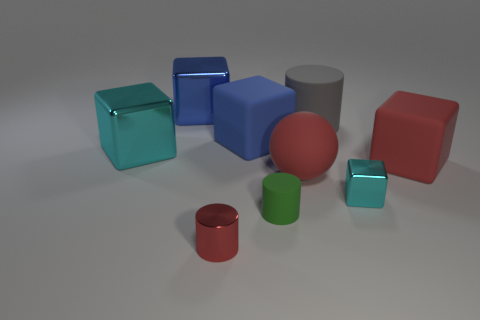How many other objects are there of the same color as the big rubber sphere?
Offer a terse response. 2. What size is the shiny cylinder that is the same color as the big matte sphere?
Provide a short and direct response. Small. How many large objects are either matte cubes or green matte things?
Offer a terse response. 2. Are there more blue metal cubes that are in front of the small red cylinder than small cubes that are left of the ball?
Offer a very short reply. No. Is the tiny red cylinder made of the same material as the large cube right of the green object?
Your answer should be very brief. No. What is the color of the tiny metallic block?
Your response must be concise. Cyan. There is a large metal object that is behind the big gray matte thing; what is its shape?
Make the answer very short. Cube. What number of red things are either big cubes or small cylinders?
Your answer should be compact. 2. The small cylinder that is the same material as the large gray cylinder is what color?
Offer a terse response. Green. Do the big rubber ball and the cylinder on the right side of the green cylinder have the same color?
Your response must be concise. No. 